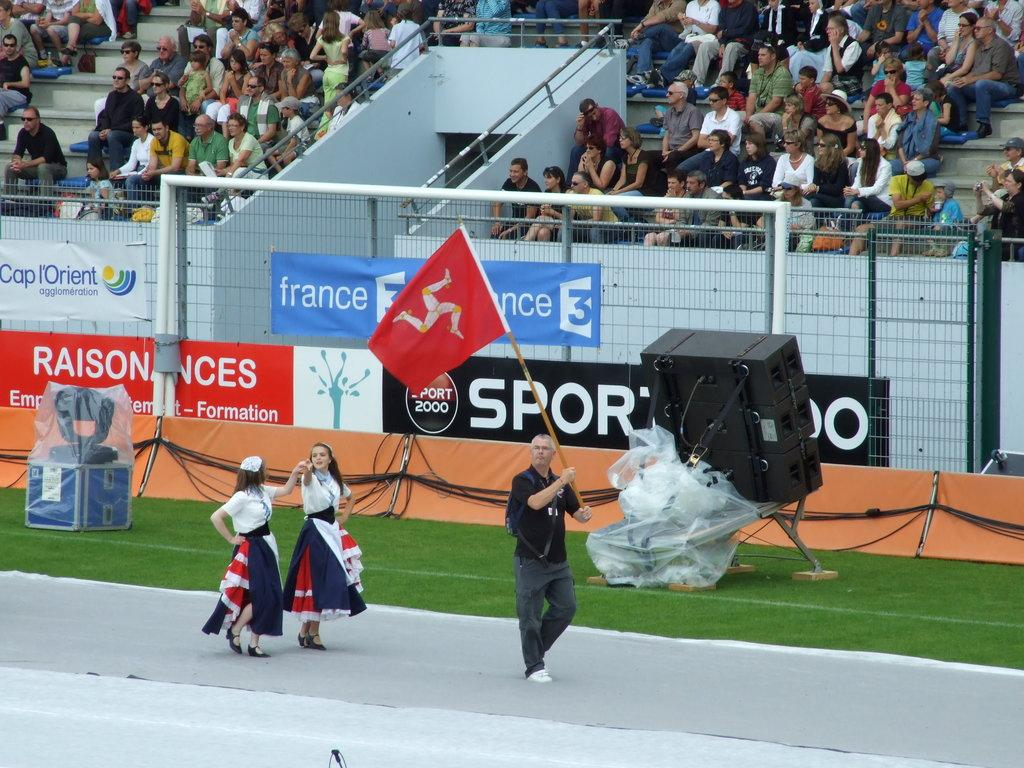<image>
Render a clear and concise summary of the photo. Three people in a small parade walking in front of a large crowd sitting in the bleachers and some advertisement signs posted on the bleachers like sport and France. 